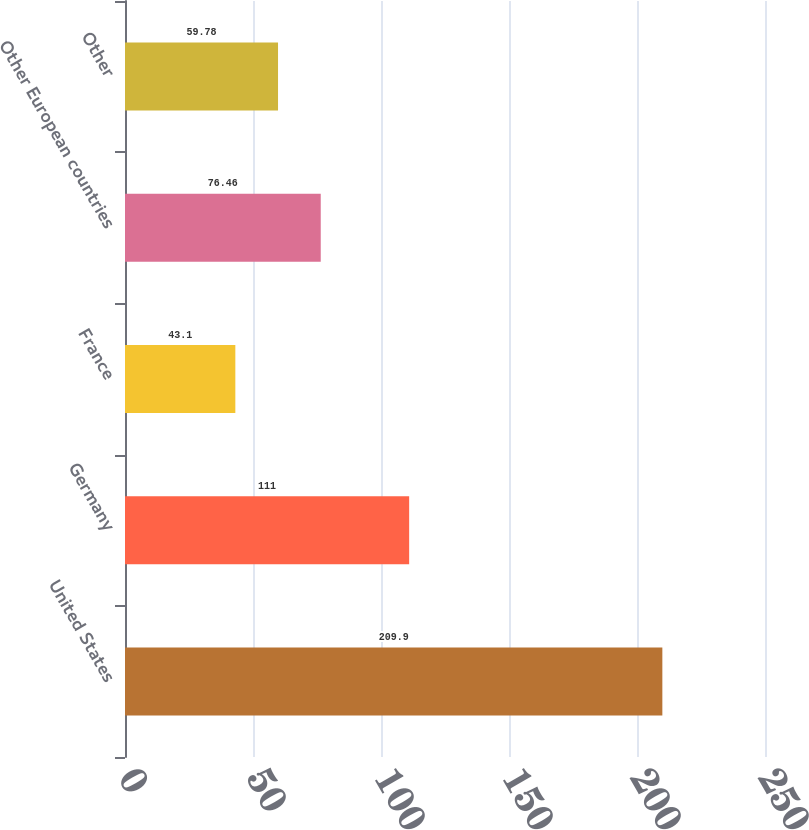Convert chart. <chart><loc_0><loc_0><loc_500><loc_500><bar_chart><fcel>United States<fcel>Germany<fcel>France<fcel>Other European countries<fcel>Other<nl><fcel>209.9<fcel>111<fcel>43.1<fcel>76.46<fcel>59.78<nl></chart> 